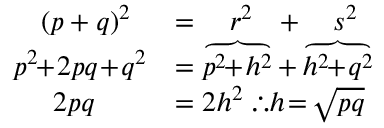<formula> <loc_0><loc_0><loc_500><loc_500>{ \begin{array} { r l } { ( p + q ) ^ { 2 } \, } & { = \quad r ^ { 2 } \, + \quad s ^ { 2 } } \\ { p ^ { 2 } \, + \, 2 p q \, + \, q ^ { 2 } } & { = \overbrace { p ^ { 2 } \, + \, h ^ { 2 } } + \overbrace { h ^ { 2 } \, + \, q ^ { 2 } } } \\ { 2 p q \quad \, } & { = 2 h ^ { 2 } \, \therefore h \, = \, { \sqrt { p q } } } \end{array} }</formula> 